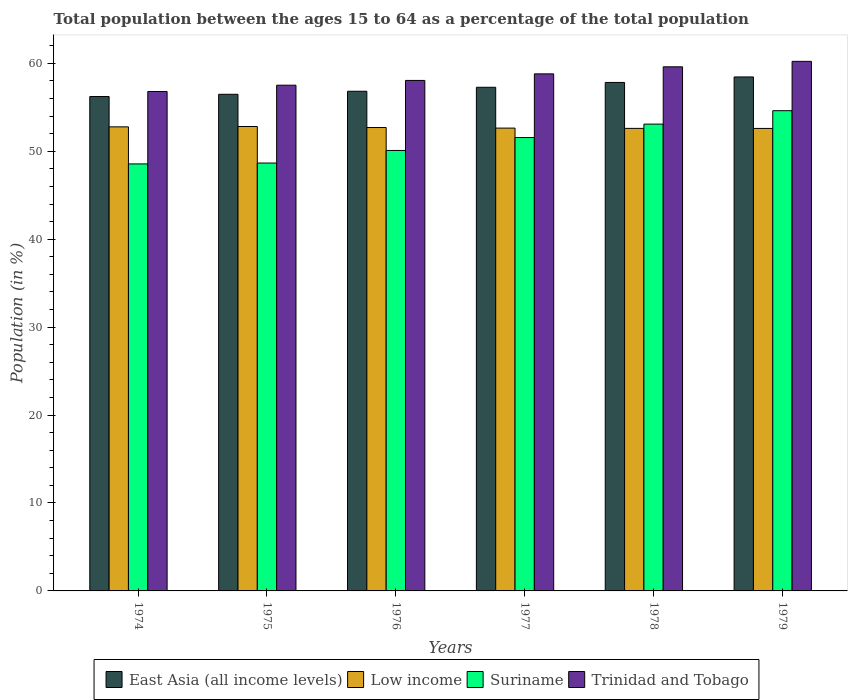How many different coloured bars are there?
Offer a terse response. 4. How many groups of bars are there?
Provide a short and direct response. 6. Are the number of bars on each tick of the X-axis equal?
Ensure brevity in your answer.  Yes. How many bars are there on the 3rd tick from the right?
Offer a terse response. 4. What is the label of the 3rd group of bars from the left?
Keep it short and to the point. 1976. In how many cases, is the number of bars for a given year not equal to the number of legend labels?
Your answer should be compact. 0. What is the percentage of the population ages 15 to 64 in Trinidad and Tobago in 1976?
Your answer should be compact. 58.06. Across all years, what is the maximum percentage of the population ages 15 to 64 in Suriname?
Keep it short and to the point. 54.61. Across all years, what is the minimum percentage of the population ages 15 to 64 in Low income?
Your response must be concise. 52.6. In which year was the percentage of the population ages 15 to 64 in Low income maximum?
Provide a succinct answer. 1975. In which year was the percentage of the population ages 15 to 64 in East Asia (all income levels) minimum?
Offer a terse response. 1974. What is the total percentage of the population ages 15 to 64 in Low income in the graph?
Your response must be concise. 316.13. What is the difference between the percentage of the population ages 15 to 64 in Low income in 1974 and that in 1975?
Give a very brief answer. -0.04. What is the difference between the percentage of the population ages 15 to 64 in East Asia (all income levels) in 1975 and the percentage of the population ages 15 to 64 in Trinidad and Tobago in 1979?
Make the answer very short. -3.75. What is the average percentage of the population ages 15 to 64 in East Asia (all income levels) per year?
Offer a very short reply. 57.18. In the year 1979, what is the difference between the percentage of the population ages 15 to 64 in Low income and percentage of the population ages 15 to 64 in Suriname?
Ensure brevity in your answer.  -2.02. In how many years, is the percentage of the population ages 15 to 64 in East Asia (all income levels) greater than 12?
Make the answer very short. 6. What is the ratio of the percentage of the population ages 15 to 64 in Trinidad and Tobago in 1977 to that in 1978?
Offer a very short reply. 0.99. What is the difference between the highest and the second highest percentage of the population ages 15 to 64 in Low income?
Your answer should be compact. 0.04. What is the difference between the highest and the lowest percentage of the population ages 15 to 64 in Low income?
Your answer should be compact. 0.22. What does the 1st bar from the left in 1979 represents?
Give a very brief answer. East Asia (all income levels). What does the 4th bar from the right in 1974 represents?
Your answer should be compact. East Asia (all income levels). How many bars are there?
Offer a very short reply. 24. Does the graph contain grids?
Provide a succinct answer. No. How many legend labels are there?
Provide a short and direct response. 4. How are the legend labels stacked?
Your answer should be very brief. Horizontal. What is the title of the graph?
Your answer should be compact. Total population between the ages 15 to 64 as a percentage of the total population. Does "Euro area" appear as one of the legend labels in the graph?
Give a very brief answer. No. What is the label or title of the X-axis?
Keep it short and to the point. Years. What is the Population (in %) of East Asia (all income levels) in 1974?
Your answer should be very brief. 56.23. What is the Population (in %) in Low income in 1974?
Provide a succinct answer. 52.78. What is the Population (in %) in Suriname in 1974?
Offer a very short reply. 48.56. What is the Population (in %) of Trinidad and Tobago in 1974?
Offer a terse response. 56.8. What is the Population (in %) of East Asia (all income levels) in 1975?
Offer a very short reply. 56.48. What is the Population (in %) of Low income in 1975?
Provide a short and direct response. 52.82. What is the Population (in %) of Suriname in 1975?
Offer a terse response. 48.66. What is the Population (in %) in Trinidad and Tobago in 1975?
Your response must be concise. 57.51. What is the Population (in %) of East Asia (all income levels) in 1976?
Your answer should be very brief. 56.83. What is the Population (in %) in Low income in 1976?
Provide a succinct answer. 52.7. What is the Population (in %) of Suriname in 1976?
Ensure brevity in your answer.  50.09. What is the Population (in %) of Trinidad and Tobago in 1976?
Provide a short and direct response. 58.06. What is the Population (in %) in East Asia (all income levels) in 1977?
Offer a very short reply. 57.28. What is the Population (in %) in Low income in 1977?
Provide a short and direct response. 52.63. What is the Population (in %) of Suriname in 1977?
Your answer should be compact. 51.56. What is the Population (in %) in Trinidad and Tobago in 1977?
Ensure brevity in your answer.  58.8. What is the Population (in %) of East Asia (all income levels) in 1978?
Ensure brevity in your answer.  57.83. What is the Population (in %) in Low income in 1978?
Your response must be concise. 52.6. What is the Population (in %) in Suriname in 1978?
Give a very brief answer. 53.09. What is the Population (in %) in Trinidad and Tobago in 1978?
Make the answer very short. 59.6. What is the Population (in %) in East Asia (all income levels) in 1979?
Your response must be concise. 58.45. What is the Population (in %) of Low income in 1979?
Offer a very short reply. 52.6. What is the Population (in %) of Suriname in 1979?
Make the answer very short. 54.61. What is the Population (in %) of Trinidad and Tobago in 1979?
Provide a succinct answer. 60.23. Across all years, what is the maximum Population (in %) of East Asia (all income levels)?
Your response must be concise. 58.45. Across all years, what is the maximum Population (in %) in Low income?
Provide a short and direct response. 52.82. Across all years, what is the maximum Population (in %) of Suriname?
Offer a very short reply. 54.61. Across all years, what is the maximum Population (in %) of Trinidad and Tobago?
Your response must be concise. 60.23. Across all years, what is the minimum Population (in %) of East Asia (all income levels)?
Your response must be concise. 56.23. Across all years, what is the minimum Population (in %) of Low income?
Offer a terse response. 52.6. Across all years, what is the minimum Population (in %) in Suriname?
Your answer should be very brief. 48.56. Across all years, what is the minimum Population (in %) in Trinidad and Tobago?
Give a very brief answer. 56.8. What is the total Population (in %) of East Asia (all income levels) in the graph?
Provide a succinct answer. 343.09. What is the total Population (in %) in Low income in the graph?
Ensure brevity in your answer.  316.13. What is the total Population (in %) of Suriname in the graph?
Offer a terse response. 306.58. What is the total Population (in %) of Trinidad and Tobago in the graph?
Your response must be concise. 351. What is the difference between the Population (in %) in East Asia (all income levels) in 1974 and that in 1975?
Offer a terse response. -0.26. What is the difference between the Population (in %) of Low income in 1974 and that in 1975?
Provide a succinct answer. -0.04. What is the difference between the Population (in %) in Suriname in 1974 and that in 1975?
Provide a succinct answer. -0.1. What is the difference between the Population (in %) of Trinidad and Tobago in 1974 and that in 1975?
Provide a succinct answer. -0.72. What is the difference between the Population (in %) of East Asia (all income levels) in 1974 and that in 1976?
Offer a terse response. -0.6. What is the difference between the Population (in %) in Low income in 1974 and that in 1976?
Provide a succinct answer. 0.08. What is the difference between the Population (in %) in Suriname in 1974 and that in 1976?
Make the answer very short. -1.53. What is the difference between the Population (in %) of Trinidad and Tobago in 1974 and that in 1976?
Ensure brevity in your answer.  -1.26. What is the difference between the Population (in %) in East Asia (all income levels) in 1974 and that in 1977?
Ensure brevity in your answer.  -1.05. What is the difference between the Population (in %) in Low income in 1974 and that in 1977?
Your response must be concise. 0.14. What is the difference between the Population (in %) of Suriname in 1974 and that in 1977?
Provide a succinct answer. -3. What is the difference between the Population (in %) of Trinidad and Tobago in 1974 and that in 1977?
Ensure brevity in your answer.  -2.01. What is the difference between the Population (in %) in East Asia (all income levels) in 1974 and that in 1978?
Your answer should be compact. -1.6. What is the difference between the Population (in %) of Low income in 1974 and that in 1978?
Offer a very short reply. 0.17. What is the difference between the Population (in %) of Suriname in 1974 and that in 1978?
Keep it short and to the point. -4.53. What is the difference between the Population (in %) of Trinidad and Tobago in 1974 and that in 1978?
Make the answer very short. -2.81. What is the difference between the Population (in %) of East Asia (all income levels) in 1974 and that in 1979?
Ensure brevity in your answer.  -2.23. What is the difference between the Population (in %) of Low income in 1974 and that in 1979?
Make the answer very short. 0.18. What is the difference between the Population (in %) of Suriname in 1974 and that in 1979?
Offer a terse response. -6.05. What is the difference between the Population (in %) in Trinidad and Tobago in 1974 and that in 1979?
Provide a succinct answer. -3.43. What is the difference between the Population (in %) of East Asia (all income levels) in 1975 and that in 1976?
Provide a succinct answer. -0.34. What is the difference between the Population (in %) of Low income in 1975 and that in 1976?
Offer a terse response. 0.11. What is the difference between the Population (in %) of Suriname in 1975 and that in 1976?
Offer a terse response. -1.43. What is the difference between the Population (in %) of Trinidad and Tobago in 1975 and that in 1976?
Your answer should be compact. -0.54. What is the difference between the Population (in %) in East Asia (all income levels) in 1975 and that in 1977?
Offer a terse response. -0.8. What is the difference between the Population (in %) of Low income in 1975 and that in 1977?
Provide a succinct answer. 0.18. What is the difference between the Population (in %) of Suriname in 1975 and that in 1977?
Provide a short and direct response. -2.9. What is the difference between the Population (in %) in Trinidad and Tobago in 1975 and that in 1977?
Give a very brief answer. -1.29. What is the difference between the Population (in %) of East Asia (all income levels) in 1975 and that in 1978?
Provide a short and direct response. -1.35. What is the difference between the Population (in %) in Low income in 1975 and that in 1978?
Ensure brevity in your answer.  0.21. What is the difference between the Population (in %) in Suriname in 1975 and that in 1978?
Your response must be concise. -4.43. What is the difference between the Population (in %) in Trinidad and Tobago in 1975 and that in 1978?
Provide a short and direct response. -2.09. What is the difference between the Population (in %) of East Asia (all income levels) in 1975 and that in 1979?
Keep it short and to the point. -1.97. What is the difference between the Population (in %) in Low income in 1975 and that in 1979?
Provide a succinct answer. 0.22. What is the difference between the Population (in %) in Suriname in 1975 and that in 1979?
Your answer should be compact. -5.95. What is the difference between the Population (in %) in Trinidad and Tobago in 1975 and that in 1979?
Your response must be concise. -2.71. What is the difference between the Population (in %) in East Asia (all income levels) in 1976 and that in 1977?
Your response must be concise. -0.45. What is the difference between the Population (in %) in Low income in 1976 and that in 1977?
Ensure brevity in your answer.  0.07. What is the difference between the Population (in %) of Suriname in 1976 and that in 1977?
Provide a short and direct response. -1.47. What is the difference between the Population (in %) of Trinidad and Tobago in 1976 and that in 1977?
Offer a very short reply. -0.75. What is the difference between the Population (in %) in East Asia (all income levels) in 1976 and that in 1978?
Ensure brevity in your answer.  -1. What is the difference between the Population (in %) in Low income in 1976 and that in 1978?
Give a very brief answer. 0.1. What is the difference between the Population (in %) in Suriname in 1976 and that in 1978?
Your answer should be compact. -3. What is the difference between the Population (in %) in Trinidad and Tobago in 1976 and that in 1978?
Offer a terse response. -1.55. What is the difference between the Population (in %) in East Asia (all income levels) in 1976 and that in 1979?
Your answer should be very brief. -1.63. What is the difference between the Population (in %) of Low income in 1976 and that in 1979?
Offer a very short reply. 0.1. What is the difference between the Population (in %) of Suriname in 1976 and that in 1979?
Your answer should be very brief. -4.52. What is the difference between the Population (in %) in Trinidad and Tobago in 1976 and that in 1979?
Make the answer very short. -2.17. What is the difference between the Population (in %) in East Asia (all income levels) in 1977 and that in 1978?
Your answer should be compact. -0.55. What is the difference between the Population (in %) of Low income in 1977 and that in 1978?
Offer a very short reply. 0.03. What is the difference between the Population (in %) in Suriname in 1977 and that in 1978?
Keep it short and to the point. -1.53. What is the difference between the Population (in %) in Trinidad and Tobago in 1977 and that in 1978?
Your answer should be compact. -0.8. What is the difference between the Population (in %) in East Asia (all income levels) in 1977 and that in 1979?
Ensure brevity in your answer.  -1.17. What is the difference between the Population (in %) of Low income in 1977 and that in 1979?
Make the answer very short. 0.04. What is the difference between the Population (in %) of Suriname in 1977 and that in 1979?
Keep it short and to the point. -3.05. What is the difference between the Population (in %) in Trinidad and Tobago in 1977 and that in 1979?
Provide a short and direct response. -1.42. What is the difference between the Population (in %) in East Asia (all income levels) in 1978 and that in 1979?
Provide a short and direct response. -0.62. What is the difference between the Population (in %) of Low income in 1978 and that in 1979?
Provide a succinct answer. 0. What is the difference between the Population (in %) in Suriname in 1978 and that in 1979?
Your answer should be very brief. -1.52. What is the difference between the Population (in %) of Trinidad and Tobago in 1978 and that in 1979?
Provide a succinct answer. -0.62. What is the difference between the Population (in %) in East Asia (all income levels) in 1974 and the Population (in %) in Low income in 1975?
Your response must be concise. 3.41. What is the difference between the Population (in %) of East Asia (all income levels) in 1974 and the Population (in %) of Suriname in 1975?
Your response must be concise. 7.56. What is the difference between the Population (in %) in East Asia (all income levels) in 1974 and the Population (in %) in Trinidad and Tobago in 1975?
Your answer should be very brief. -1.29. What is the difference between the Population (in %) in Low income in 1974 and the Population (in %) in Suriname in 1975?
Your answer should be very brief. 4.11. What is the difference between the Population (in %) in Low income in 1974 and the Population (in %) in Trinidad and Tobago in 1975?
Make the answer very short. -4.74. What is the difference between the Population (in %) of Suriname in 1974 and the Population (in %) of Trinidad and Tobago in 1975?
Your answer should be compact. -8.95. What is the difference between the Population (in %) of East Asia (all income levels) in 1974 and the Population (in %) of Low income in 1976?
Your response must be concise. 3.52. What is the difference between the Population (in %) in East Asia (all income levels) in 1974 and the Population (in %) in Suriname in 1976?
Give a very brief answer. 6.13. What is the difference between the Population (in %) in East Asia (all income levels) in 1974 and the Population (in %) in Trinidad and Tobago in 1976?
Give a very brief answer. -1.83. What is the difference between the Population (in %) of Low income in 1974 and the Population (in %) of Suriname in 1976?
Offer a terse response. 2.68. What is the difference between the Population (in %) in Low income in 1974 and the Population (in %) in Trinidad and Tobago in 1976?
Provide a succinct answer. -5.28. What is the difference between the Population (in %) of Suriname in 1974 and the Population (in %) of Trinidad and Tobago in 1976?
Provide a short and direct response. -9.5. What is the difference between the Population (in %) in East Asia (all income levels) in 1974 and the Population (in %) in Low income in 1977?
Your answer should be compact. 3.59. What is the difference between the Population (in %) of East Asia (all income levels) in 1974 and the Population (in %) of Suriname in 1977?
Provide a succinct answer. 4.66. What is the difference between the Population (in %) in East Asia (all income levels) in 1974 and the Population (in %) in Trinidad and Tobago in 1977?
Your answer should be compact. -2.58. What is the difference between the Population (in %) in Low income in 1974 and the Population (in %) in Suriname in 1977?
Give a very brief answer. 1.21. What is the difference between the Population (in %) of Low income in 1974 and the Population (in %) of Trinidad and Tobago in 1977?
Provide a short and direct response. -6.03. What is the difference between the Population (in %) in Suriname in 1974 and the Population (in %) in Trinidad and Tobago in 1977?
Ensure brevity in your answer.  -10.24. What is the difference between the Population (in %) of East Asia (all income levels) in 1974 and the Population (in %) of Low income in 1978?
Make the answer very short. 3.62. What is the difference between the Population (in %) in East Asia (all income levels) in 1974 and the Population (in %) in Suriname in 1978?
Provide a short and direct response. 3.14. What is the difference between the Population (in %) in East Asia (all income levels) in 1974 and the Population (in %) in Trinidad and Tobago in 1978?
Your answer should be compact. -3.38. What is the difference between the Population (in %) in Low income in 1974 and the Population (in %) in Suriname in 1978?
Offer a very short reply. -0.31. What is the difference between the Population (in %) in Low income in 1974 and the Population (in %) in Trinidad and Tobago in 1978?
Ensure brevity in your answer.  -6.83. What is the difference between the Population (in %) in Suriname in 1974 and the Population (in %) in Trinidad and Tobago in 1978?
Provide a succinct answer. -11.04. What is the difference between the Population (in %) of East Asia (all income levels) in 1974 and the Population (in %) of Low income in 1979?
Your answer should be compact. 3.63. What is the difference between the Population (in %) of East Asia (all income levels) in 1974 and the Population (in %) of Suriname in 1979?
Ensure brevity in your answer.  1.61. What is the difference between the Population (in %) in East Asia (all income levels) in 1974 and the Population (in %) in Trinidad and Tobago in 1979?
Make the answer very short. -4. What is the difference between the Population (in %) of Low income in 1974 and the Population (in %) of Suriname in 1979?
Provide a short and direct response. -1.84. What is the difference between the Population (in %) of Low income in 1974 and the Population (in %) of Trinidad and Tobago in 1979?
Your answer should be compact. -7.45. What is the difference between the Population (in %) of Suriname in 1974 and the Population (in %) of Trinidad and Tobago in 1979?
Provide a succinct answer. -11.66. What is the difference between the Population (in %) in East Asia (all income levels) in 1975 and the Population (in %) in Low income in 1976?
Give a very brief answer. 3.78. What is the difference between the Population (in %) of East Asia (all income levels) in 1975 and the Population (in %) of Suriname in 1976?
Your answer should be very brief. 6.39. What is the difference between the Population (in %) of East Asia (all income levels) in 1975 and the Population (in %) of Trinidad and Tobago in 1976?
Provide a succinct answer. -1.58. What is the difference between the Population (in %) of Low income in 1975 and the Population (in %) of Suriname in 1976?
Make the answer very short. 2.72. What is the difference between the Population (in %) in Low income in 1975 and the Population (in %) in Trinidad and Tobago in 1976?
Ensure brevity in your answer.  -5.24. What is the difference between the Population (in %) of Suriname in 1975 and the Population (in %) of Trinidad and Tobago in 1976?
Make the answer very short. -9.4. What is the difference between the Population (in %) in East Asia (all income levels) in 1975 and the Population (in %) in Low income in 1977?
Your response must be concise. 3.85. What is the difference between the Population (in %) in East Asia (all income levels) in 1975 and the Population (in %) in Suriname in 1977?
Offer a very short reply. 4.92. What is the difference between the Population (in %) in East Asia (all income levels) in 1975 and the Population (in %) in Trinidad and Tobago in 1977?
Offer a terse response. -2.32. What is the difference between the Population (in %) in Low income in 1975 and the Population (in %) in Suriname in 1977?
Provide a short and direct response. 1.25. What is the difference between the Population (in %) of Low income in 1975 and the Population (in %) of Trinidad and Tobago in 1977?
Your answer should be very brief. -5.99. What is the difference between the Population (in %) of Suriname in 1975 and the Population (in %) of Trinidad and Tobago in 1977?
Your response must be concise. -10.14. What is the difference between the Population (in %) of East Asia (all income levels) in 1975 and the Population (in %) of Low income in 1978?
Make the answer very short. 3.88. What is the difference between the Population (in %) in East Asia (all income levels) in 1975 and the Population (in %) in Suriname in 1978?
Offer a terse response. 3.39. What is the difference between the Population (in %) in East Asia (all income levels) in 1975 and the Population (in %) in Trinidad and Tobago in 1978?
Your response must be concise. -3.12. What is the difference between the Population (in %) of Low income in 1975 and the Population (in %) of Suriname in 1978?
Your response must be concise. -0.27. What is the difference between the Population (in %) of Low income in 1975 and the Population (in %) of Trinidad and Tobago in 1978?
Ensure brevity in your answer.  -6.79. What is the difference between the Population (in %) of Suriname in 1975 and the Population (in %) of Trinidad and Tobago in 1978?
Your answer should be compact. -10.94. What is the difference between the Population (in %) of East Asia (all income levels) in 1975 and the Population (in %) of Low income in 1979?
Your response must be concise. 3.88. What is the difference between the Population (in %) in East Asia (all income levels) in 1975 and the Population (in %) in Suriname in 1979?
Offer a very short reply. 1.87. What is the difference between the Population (in %) of East Asia (all income levels) in 1975 and the Population (in %) of Trinidad and Tobago in 1979?
Make the answer very short. -3.75. What is the difference between the Population (in %) of Low income in 1975 and the Population (in %) of Suriname in 1979?
Your answer should be compact. -1.8. What is the difference between the Population (in %) of Low income in 1975 and the Population (in %) of Trinidad and Tobago in 1979?
Offer a terse response. -7.41. What is the difference between the Population (in %) in Suriname in 1975 and the Population (in %) in Trinidad and Tobago in 1979?
Give a very brief answer. -11.56. What is the difference between the Population (in %) of East Asia (all income levels) in 1976 and the Population (in %) of Low income in 1977?
Ensure brevity in your answer.  4.19. What is the difference between the Population (in %) of East Asia (all income levels) in 1976 and the Population (in %) of Suriname in 1977?
Your answer should be compact. 5.26. What is the difference between the Population (in %) of East Asia (all income levels) in 1976 and the Population (in %) of Trinidad and Tobago in 1977?
Provide a short and direct response. -1.98. What is the difference between the Population (in %) in Low income in 1976 and the Population (in %) in Suriname in 1977?
Your answer should be compact. 1.14. What is the difference between the Population (in %) in Low income in 1976 and the Population (in %) in Trinidad and Tobago in 1977?
Ensure brevity in your answer.  -6.1. What is the difference between the Population (in %) of Suriname in 1976 and the Population (in %) of Trinidad and Tobago in 1977?
Offer a terse response. -8.71. What is the difference between the Population (in %) of East Asia (all income levels) in 1976 and the Population (in %) of Low income in 1978?
Provide a succinct answer. 4.22. What is the difference between the Population (in %) of East Asia (all income levels) in 1976 and the Population (in %) of Suriname in 1978?
Your answer should be compact. 3.74. What is the difference between the Population (in %) of East Asia (all income levels) in 1976 and the Population (in %) of Trinidad and Tobago in 1978?
Keep it short and to the point. -2.78. What is the difference between the Population (in %) of Low income in 1976 and the Population (in %) of Suriname in 1978?
Offer a very short reply. -0.39. What is the difference between the Population (in %) of Low income in 1976 and the Population (in %) of Trinidad and Tobago in 1978?
Your answer should be compact. -6.9. What is the difference between the Population (in %) in Suriname in 1976 and the Population (in %) in Trinidad and Tobago in 1978?
Keep it short and to the point. -9.51. What is the difference between the Population (in %) in East Asia (all income levels) in 1976 and the Population (in %) in Low income in 1979?
Keep it short and to the point. 4.23. What is the difference between the Population (in %) of East Asia (all income levels) in 1976 and the Population (in %) of Suriname in 1979?
Provide a succinct answer. 2.21. What is the difference between the Population (in %) of East Asia (all income levels) in 1976 and the Population (in %) of Trinidad and Tobago in 1979?
Make the answer very short. -3.4. What is the difference between the Population (in %) in Low income in 1976 and the Population (in %) in Suriname in 1979?
Provide a short and direct response. -1.91. What is the difference between the Population (in %) in Low income in 1976 and the Population (in %) in Trinidad and Tobago in 1979?
Offer a terse response. -7.52. What is the difference between the Population (in %) in Suriname in 1976 and the Population (in %) in Trinidad and Tobago in 1979?
Keep it short and to the point. -10.13. What is the difference between the Population (in %) of East Asia (all income levels) in 1977 and the Population (in %) of Low income in 1978?
Provide a short and direct response. 4.67. What is the difference between the Population (in %) of East Asia (all income levels) in 1977 and the Population (in %) of Suriname in 1978?
Give a very brief answer. 4.19. What is the difference between the Population (in %) of East Asia (all income levels) in 1977 and the Population (in %) of Trinidad and Tobago in 1978?
Provide a succinct answer. -2.33. What is the difference between the Population (in %) in Low income in 1977 and the Population (in %) in Suriname in 1978?
Keep it short and to the point. -0.45. What is the difference between the Population (in %) of Low income in 1977 and the Population (in %) of Trinidad and Tobago in 1978?
Give a very brief answer. -6.97. What is the difference between the Population (in %) of Suriname in 1977 and the Population (in %) of Trinidad and Tobago in 1978?
Offer a very short reply. -8.04. What is the difference between the Population (in %) of East Asia (all income levels) in 1977 and the Population (in %) of Low income in 1979?
Keep it short and to the point. 4.68. What is the difference between the Population (in %) of East Asia (all income levels) in 1977 and the Population (in %) of Suriname in 1979?
Make the answer very short. 2.66. What is the difference between the Population (in %) in East Asia (all income levels) in 1977 and the Population (in %) in Trinidad and Tobago in 1979?
Provide a short and direct response. -2.95. What is the difference between the Population (in %) of Low income in 1977 and the Population (in %) of Suriname in 1979?
Give a very brief answer. -1.98. What is the difference between the Population (in %) in Low income in 1977 and the Population (in %) in Trinidad and Tobago in 1979?
Offer a very short reply. -7.59. What is the difference between the Population (in %) of Suriname in 1977 and the Population (in %) of Trinidad and Tobago in 1979?
Your answer should be compact. -8.66. What is the difference between the Population (in %) in East Asia (all income levels) in 1978 and the Population (in %) in Low income in 1979?
Keep it short and to the point. 5.23. What is the difference between the Population (in %) in East Asia (all income levels) in 1978 and the Population (in %) in Suriname in 1979?
Provide a short and direct response. 3.21. What is the difference between the Population (in %) of East Asia (all income levels) in 1978 and the Population (in %) of Trinidad and Tobago in 1979?
Provide a succinct answer. -2.4. What is the difference between the Population (in %) of Low income in 1978 and the Population (in %) of Suriname in 1979?
Give a very brief answer. -2.01. What is the difference between the Population (in %) of Low income in 1978 and the Population (in %) of Trinidad and Tobago in 1979?
Make the answer very short. -7.62. What is the difference between the Population (in %) in Suriname in 1978 and the Population (in %) in Trinidad and Tobago in 1979?
Make the answer very short. -7.14. What is the average Population (in %) in East Asia (all income levels) per year?
Your answer should be compact. 57.18. What is the average Population (in %) of Low income per year?
Provide a short and direct response. 52.69. What is the average Population (in %) of Suriname per year?
Ensure brevity in your answer.  51.1. What is the average Population (in %) of Trinidad and Tobago per year?
Give a very brief answer. 58.5. In the year 1974, what is the difference between the Population (in %) in East Asia (all income levels) and Population (in %) in Low income?
Provide a succinct answer. 3.45. In the year 1974, what is the difference between the Population (in %) in East Asia (all income levels) and Population (in %) in Suriname?
Give a very brief answer. 7.66. In the year 1974, what is the difference between the Population (in %) in East Asia (all income levels) and Population (in %) in Trinidad and Tobago?
Provide a short and direct response. -0.57. In the year 1974, what is the difference between the Population (in %) of Low income and Population (in %) of Suriname?
Your answer should be compact. 4.21. In the year 1974, what is the difference between the Population (in %) of Low income and Population (in %) of Trinidad and Tobago?
Keep it short and to the point. -4.02. In the year 1974, what is the difference between the Population (in %) in Suriname and Population (in %) in Trinidad and Tobago?
Make the answer very short. -8.24. In the year 1975, what is the difference between the Population (in %) of East Asia (all income levels) and Population (in %) of Low income?
Your answer should be very brief. 3.66. In the year 1975, what is the difference between the Population (in %) in East Asia (all income levels) and Population (in %) in Suriname?
Your response must be concise. 7.82. In the year 1975, what is the difference between the Population (in %) in East Asia (all income levels) and Population (in %) in Trinidad and Tobago?
Offer a very short reply. -1.03. In the year 1975, what is the difference between the Population (in %) of Low income and Population (in %) of Suriname?
Offer a terse response. 4.15. In the year 1975, what is the difference between the Population (in %) of Low income and Population (in %) of Trinidad and Tobago?
Your response must be concise. -4.7. In the year 1975, what is the difference between the Population (in %) of Suriname and Population (in %) of Trinidad and Tobago?
Ensure brevity in your answer.  -8.85. In the year 1976, what is the difference between the Population (in %) of East Asia (all income levels) and Population (in %) of Low income?
Provide a short and direct response. 4.12. In the year 1976, what is the difference between the Population (in %) in East Asia (all income levels) and Population (in %) in Suriname?
Ensure brevity in your answer.  6.73. In the year 1976, what is the difference between the Population (in %) of East Asia (all income levels) and Population (in %) of Trinidad and Tobago?
Your answer should be very brief. -1.23. In the year 1976, what is the difference between the Population (in %) of Low income and Population (in %) of Suriname?
Your answer should be very brief. 2.61. In the year 1976, what is the difference between the Population (in %) in Low income and Population (in %) in Trinidad and Tobago?
Your response must be concise. -5.36. In the year 1976, what is the difference between the Population (in %) of Suriname and Population (in %) of Trinidad and Tobago?
Your response must be concise. -7.96. In the year 1977, what is the difference between the Population (in %) of East Asia (all income levels) and Population (in %) of Low income?
Your answer should be compact. 4.64. In the year 1977, what is the difference between the Population (in %) of East Asia (all income levels) and Population (in %) of Suriname?
Make the answer very short. 5.72. In the year 1977, what is the difference between the Population (in %) of East Asia (all income levels) and Population (in %) of Trinidad and Tobago?
Your answer should be compact. -1.53. In the year 1977, what is the difference between the Population (in %) of Low income and Population (in %) of Suriname?
Your answer should be compact. 1.07. In the year 1977, what is the difference between the Population (in %) of Low income and Population (in %) of Trinidad and Tobago?
Your answer should be very brief. -6.17. In the year 1977, what is the difference between the Population (in %) in Suriname and Population (in %) in Trinidad and Tobago?
Make the answer very short. -7.24. In the year 1978, what is the difference between the Population (in %) of East Asia (all income levels) and Population (in %) of Low income?
Make the answer very short. 5.22. In the year 1978, what is the difference between the Population (in %) in East Asia (all income levels) and Population (in %) in Suriname?
Your response must be concise. 4.74. In the year 1978, what is the difference between the Population (in %) in East Asia (all income levels) and Population (in %) in Trinidad and Tobago?
Offer a terse response. -1.78. In the year 1978, what is the difference between the Population (in %) of Low income and Population (in %) of Suriname?
Offer a terse response. -0.49. In the year 1978, what is the difference between the Population (in %) of Low income and Population (in %) of Trinidad and Tobago?
Make the answer very short. -7. In the year 1978, what is the difference between the Population (in %) in Suriname and Population (in %) in Trinidad and Tobago?
Offer a very short reply. -6.51. In the year 1979, what is the difference between the Population (in %) in East Asia (all income levels) and Population (in %) in Low income?
Offer a terse response. 5.85. In the year 1979, what is the difference between the Population (in %) of East Asia (all income levels) and Population (in %) of Suriname?
Your answer should be very brief. 3.84. In the year 1979, what is the difference between the Population (in %) of East Asia (all income levels) and Population (in %) of Trinidad and Tobago?
Ensure brevity in your answer.  -1.77. In the year 1979, what is the difference between the Population (in %) of Low income and Population (in %) of Suriname?
Offer a terse response. -2.02. In the year 1979, what is the difference between the Population (in %) of Low income and Population (in %) of Trinidad and Tobago?
Your response must be concise. -7.63. In the year 1979, what is the difference between the Population (in %) of Suriname and Population (in %) of Trinidad and Tobago?
Make the answer very short. -5.61. What is the ratio of the Population (in %) of Trinidad and Tobago in 1974 to that in 1975?
Ensure brevity in your answer.  0.99. What is the ratio of the Population (in %) of Suriname in 1974 to that in 1976?
Your answer should be compact. 0.97. What is the ratio of the Population (in %) of Trinidad and Tobago in 1974 to that in 1976?
Your answer should be very brief. 0.98. What is the ratio of the Population (in %) of East Asia (all income levels) in 1974 to that in 1977?
Offer a terse response. 0.98. What is the ratio of the Population (in %) in Low income in 1974 to that in 1977?
Offer a very short reply. 1. What is the ratio of the Population (in %) in Suriname in 1974 to that in 1977?
Make the answer very short. 0.94. What is the ratio of the Population (in %) of Trinidad and Tobago in 1974 to that in 1977?
Provide a short and direct response. 0.97. What is the ratio of the Population (in %) of East Asia (all income levels) in 1974 to that in 1978?
Give a very brief answer. 0.97. What is the ratio of the Population (in %) of Low income in 1974 to that in 1978?
Provide a short and direct response. 1. What is the ratio of the Population (in %) in Suriname in 1974 to that in 1978?
Offer a very short reply. 0.91. What is the ratio of the Population (in %) of Trinidad and Tobago in 1974 to that in 1978?
Ensure brevity in your answer.  0.95. What is the ratio of the Population (in %) of East Asia (all income levels) in 1974 to that in 1979?
Ensure brevity in your answer.  0.96. What is the ratio of the Population (in %) of Suriname in 1974 to that in 1979?
Offer a very short reply. 0.89. What is the ratio of the Population (in %) in Trinidad and Tobago in 1974 to that in 1979?
Offer a very short reply. 0.94. What is the ratio of the Population (in %) in East Asia (all income levels) in 1975 to that in 1976?
Give a very brief answer. 0.99. What is the ratio of the Population (in %) of Suriname in 1975 to that in 1976?
Your answer should be compact. 0.97. What is the ratio of the Population (in %) of Trinidad and Tobago in 1975 to that in 1976?
Your answer should be very brief. 0.99. What is the ratio of the Population (in %) of East Asia (all income levels) in 1975 to that in 1977?
Keep it short and to the point. 0.99. What is the ratio of the Population (in %) in Low income in 1975 to that in 1977?
Give a very brief answer. 1. What is the ratio of the Population (in %) in Suriname in 1975 to that in 1977?
Offer a very short reply. 0.94. What is the ratio of the Population (in %) of Trinidad and Tobago in 1975 to that in 1977?
Your response must be concise. 0.98. What is the ratio of the Population (in %) of East Asia (all income levels) in 1975 to that in 1978?
Make the answer very short. 0.98. What is the ratio of the Population (in %) of Low income in 1975 to that in 1978?
Make the answer very short. 1. What is the ratio of the Population (in %) in Suriname in 1975 to that in 1978?
Give a very brief answer. 0.92. What is the ratio of the Population (in %) in Trinidad and Tobago in 1975 to that in 1978?
Make the answer very short. 0.96. What is the ratio of the Population (in %) of East Asia (all income levels) in 1975 to that in 1979?
Your answer should be very brief. 0.97. What is the ratio of the Population (in %) in Suriname in 1975 to that in 1979?
Provide a short and direct response. 0.89. What is the ratio of the Population (in %) of Trinidad and Tobago in 1975 to that in 1979?
Your answer should be very brief. 0.95. What is the ratio of the Population (in %) in East Asia (all income levels) in 1976 to that in 1977?
Give a very brief answer. 0.99. What is the ratio of the Population (in %) of Suriname in 1976 to that in 1977?
Keep it short and to the point. 0.97. What is the ratio of the Population (in %) of Trinidad and Tobago in 1976 to that in 1977?
Keep it short and to the point. 0.99. What is the ratio of the Population (in %) in East Asia (all income levels) in 1976 to that in 1978?
Ensure brevity in your answer.  0.98. What is the ratio of the Population (in %) in Suriname in 1976 to that in 1978?
Your answer should be compact. 0.94. What is the ratio of the Population (in %) in Trinidad and Tobago in 1976 to that in 1978?
Provide a short and direct response. 0.97. What is the ratio of the Population (in %) in East Asia (all income levels) in 1976 to that in 1979?
Keep it short and to the point. 0.97. What is the ratio of the Population (in %) of Suriname in 1976 to that in 1979?
Offer a very short reply. 0.92. What is the ratio of the Population (in %) of Trinidad and Tobago in 1976 to that in 1979?
Your answer should be very brief. 0.96. What is the ratio of the Population (in %) in East Asia (all income levels) in 1977 to that in 1978?
Your response must be concise. 0.99. What is the ratio of the Population (in %) in Low income in 1977 to that in 1978?
Make the answer very short. 1. What is the ratio of the Population (in %) of Suriname in 1977 to that in 1978?
Offer a terse response. 0.97. What is the ratio of the Population (in %) in Trinidad and Tobago in 1977 to that in 1978?
Offer a terse response. 0.99. What is the ratio of the Population (in %) in East Asia (all income levels) in 1977 to that in 1979?
Give a very brief answer. 0.98. What is the ratio of the Population (in %) in Suriname in 1977 to that in 1979?
Offer a terse response. 0.94. What is the ratio of the Population (in %) in Trinidad and Tobago in 1977 to that in 1979?
Offer a very short reply. 0.98. What is the ratio of the Population (in %) of East Asia (all income levels) in 1978 to that in 1979?
Provide a short and direct response. 0.99. What is the ratio of the Population (in %) in Suriname in 1978 to that in 1979?
Provide a short and direct response. 0.97. What is the ratio of the Population (in %) of Trinidad and Tobago in 1978 to that in 1979?
Ensure brevity in your answer.  0.99. What is the difference between the highest and the second highest Population (in %) of Low income?
Your answer should be very brief. 0.04. What is the difference between the highest and the second highest Population (in %) of Suriname?
Offer a very short reply. 1.52. What is the difference between the highest and the second highest Population (in %) of Trinidad and Tobago?
Your answer should be compact. 0.62. What is the difference between the highest and the lowest Population (in %) of East Asia (all income levels)?
Offer a terse response. 2.23. What is the difference between the highest and the lowest Population (in %) of Low income?
Your answer should be compact. 0.22. What is the difference between the highest and the lowest Population (in %) of Suriname?
Keep it short and to the point. 6.05. What is the difference between the highest and the lowest Population (in %) of Trinidad and Tobago?
Your response must be concise. 3.43. 